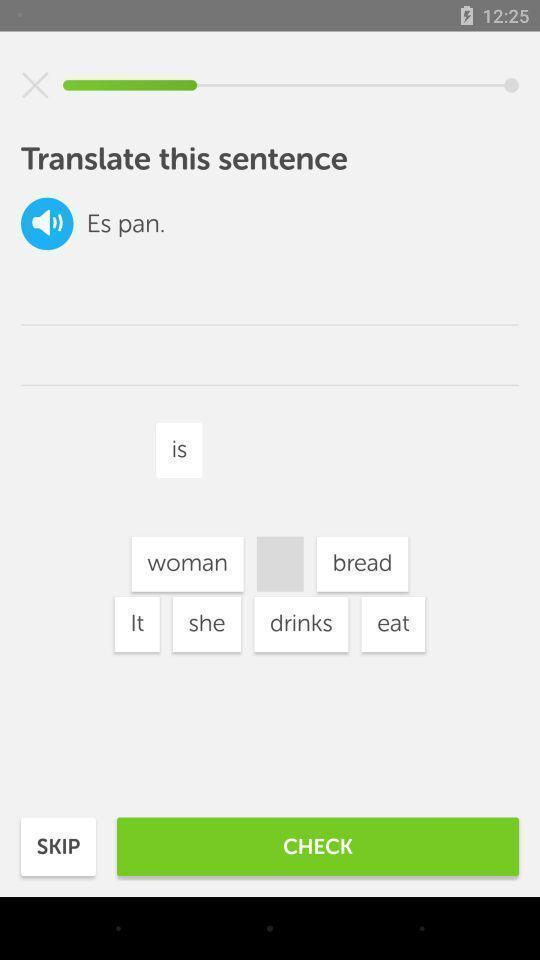Summarize the main components in this picture. Translation page is being displayed in the app. 